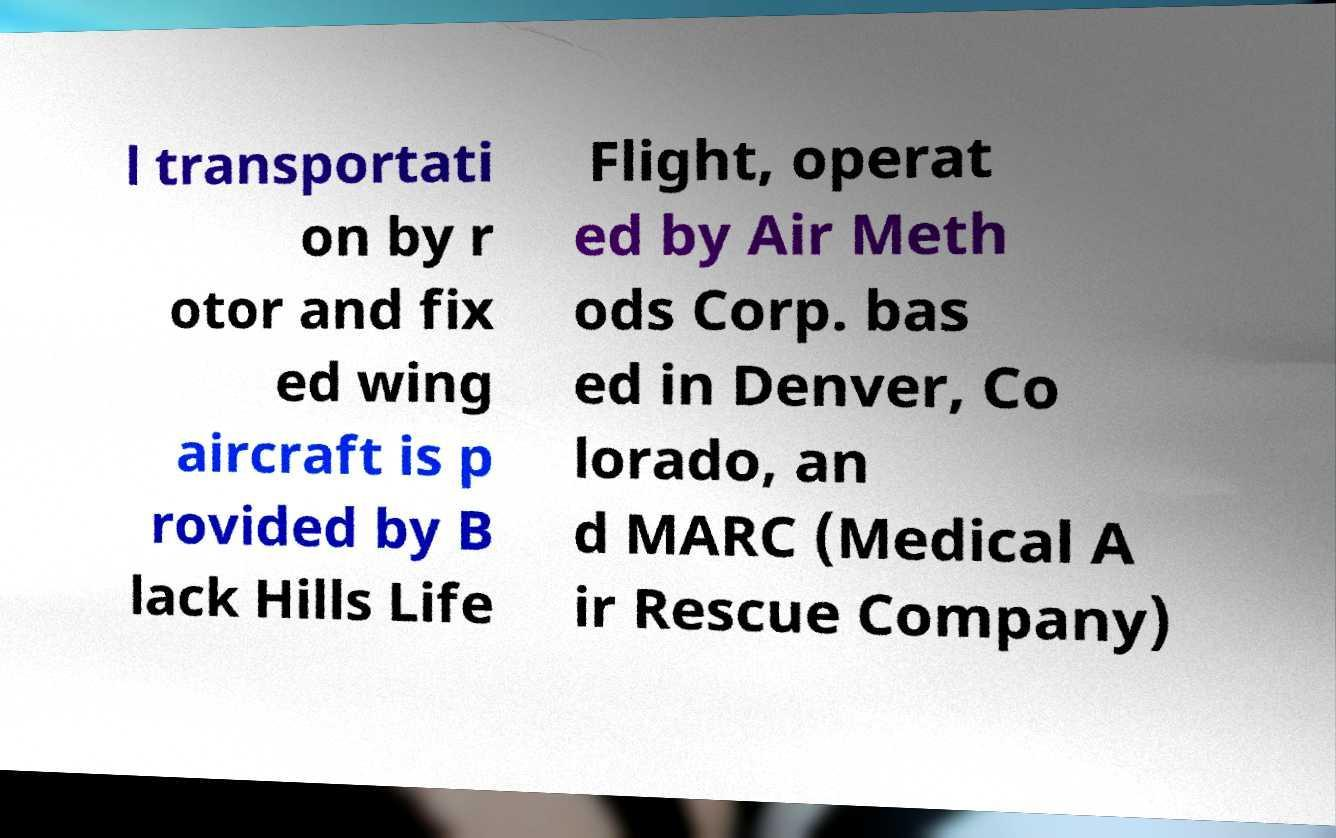Can you read and provide the text displayed in the image?This photo seems to have some interesting text. Can you extract and type it out for me? l transportati on by r otor and fix ed wing aircraft is p rovided by B lack Hills Life Flight, operat ed by Air Meth ods Corp. bas ed in Denver, Co lorado, an d MARC (Medical A ir Rescue Company) 